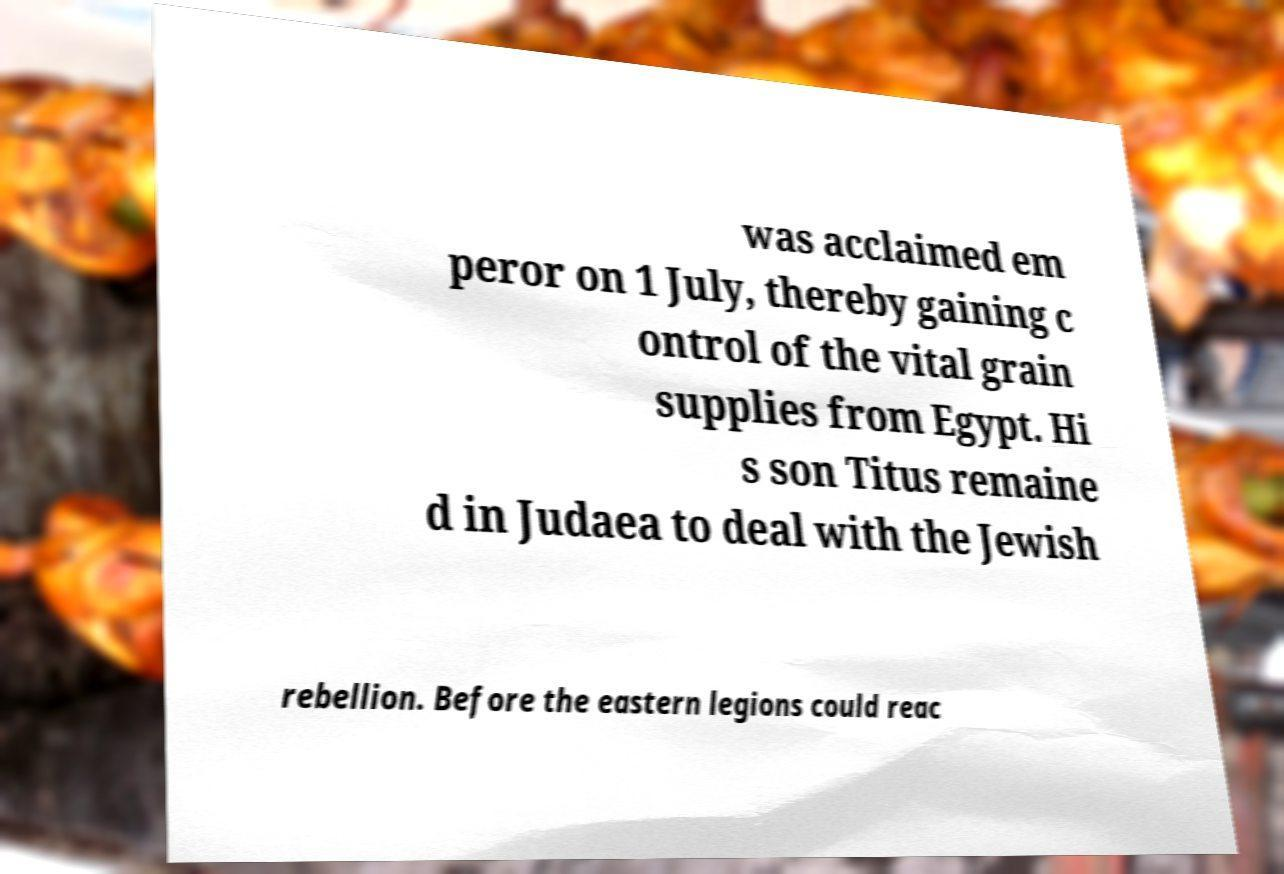Please identify and transcribe the text found in this image. was acclaimed em peror on 1 July, thereby gaining c ontrol of the vital grain supplies from Egypt. Hi s son Titus remaine d in Judaea to deal with the Jewish rebellion. Before the eastern legions could reac 